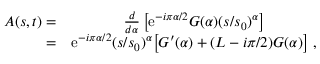Convert formula to latex. <formula><loc_0><loc_0><loc_500><loc_500>\begin{array} { r c l } { A ( s , t ) = } & { { { \frac { d } { d \alpha } } \left [ e ^ { - i \pi \alpha / 2 } G ( \alpha ) ( s / s _ { 0 } ) ^ { \alpha } \right ] } } \\ { = } & { { e ^ { - i \pi \alpha / 2 } ( s / s _ { 0 } ) ^ { \alpha } \left [ G ^ { \prime } ( \alpha ) + ( L - i \pi / 2 ) G ( \alpha ) \right ] \ , } } \end{array}</formula> 